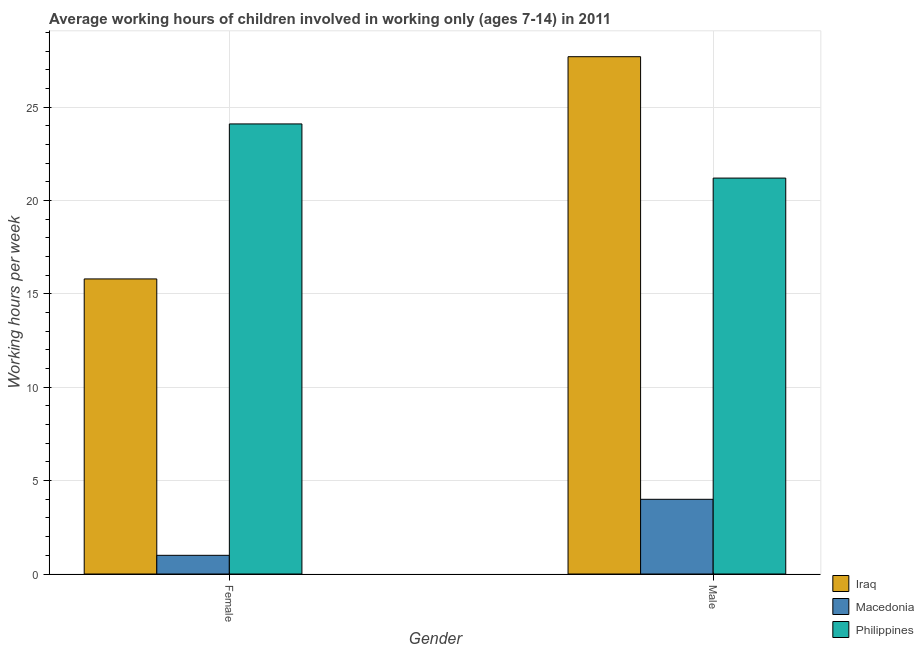Are the number of bars per tick equal to the number of legend labels?
Your answer should be very brief. Yes. How many bars are there on the 2nd tick from the left?
Provide a succinct answer. 3. How many bars are there on the 2nd tick from the right?
Provide a succinct answer. 3. What is the average working hour of female children in Philippines?
Your response must be concise. 24.1. Across all countries, what is the maximum average working hour of male children?
Ensure brevity in your answer.  27.7. In which country was the average working hour of female children minimum?
Provide a short and direct response. Macedonia. What is the total average working hour of female children in the graph?
Make the answer very short. 40.9. What is the difference between the average working hour of female children in Macedonia and that in Philippines?
Make the answer very short. -23.1. What is the difference between the average working hour of male children in Iraq and the average working hour of female children in Philippines?
Provide a short and direct response. 3.6. What is the average average working hour of male children per country?
Provide a succinct answer. 17.63. What is the difference between the average working hour of female children and average working hour of male children in Iraq?
Provide a short and direct response. -11.9. What is the ratio of the average working hour of male children in Iraq to that in Macedonia?
Ensure brevity in your answer.  6.92. In how many countries, is the average working hour of female children greater than the average average working hour of female children taken over all countries?
Give a very brief answer. 2. What does the 3rd bar from the right in Female represents?
Give a very brief answer. Iraq. Are all the bars in the graph horizontal?
Provide a short and direct response. No. How many countries are there in the graph?
Give a very brief answer. 3. Are the values on the major ticks of Y-axis written in scientific E-notation?
Make the answer very short. No. Does the graph contain any zero values?
Provide a succinct answer. No. Does the graph contain grids?
Offer a very short reply. Yes. How many legend labels are there?
Your answer should be very brief. 3. How are the legend labels stacked?
Provide a short and direct response. Vertical. What is the title of the graph?
Your answer should be compact. Average working hours of children involved in working only (ages 7-14) in 2011. Does "Gambia, The" appear as one of the legend labels in the graph?
Your answer should be very brief. No. What is the label or title of the Y-axis?
Ensure brevity in your answer.  Working hours per week. What is the Working hours per week in Iraq in Female?
Make the answer very short. 15.8. What is the Working hours per week of Macedonia in Female?
Offer a very short reply. 1. What is the Working hours per week of Philippines in Female?
Provide a succinct answer. 24.1. What is the Working hours per week of Iraq in Male?
Give a very brief answer. 27.7. What is the Working hours per week in Philippines in Male?
Provide a short and direct response. 21.2. Across all Gender, what is the maximum Working hours per week in Iraq?
Give a very brief answer. 27.7. Across all Gender, what is the maximum Working hours per week in Macedonia?
Offer a very short reply. 4. Across all Gender, what is the maximum Working hours per week in Philippines?
Ensure brevity in your answer.  24.1. Across all Gender, what is the minimum Working hours per week in Iraq?
Your answer should be very brief. 15.8. Across all Gender, what is the minimum Working hours per week in Philippines?
Offer a very short reply. 21.2. What is the total Working hours per week in Iraq in the graph?
Keep it short and to the point. 43.5. What is the total Working hours per week of Macedonia in the graph?
Keep it short and to the point. 5. What is the total Working hours per week of Philippines in the graph?
Provide a succinct answer. 45.3. What is the difference between the Working hours per week in Iraq in Female and that in Male?
Keep it short and to the point. -11.9. What is the difference between the Working hours per week of Macedonia in Female and that in Male?
Ensure brevity in your answer.  -3. What is the difference between the Working hours per week in Iraq in Female and the Working hours per week in Philippines in Male?
Provide a succinct answer. -5.4. What is the difference between the Working hours per week in Macedonia in Female and the Working hours per week in Philippines in Male?
Your answer should be very brief. -20.2. What is the average Working hours per week of Iraq per Gender?
Make the answer very short. 21.75. What is the average Working hours per week in Macedonia per Gender?
Ensure brevity in your answer.  2.5. What is the average Working hours per week in Philippines per Gender?
Your answer should be compact. 22.65. What is the difference between the Working hours per week of Macedonia and Working hours per week of Philippines in Female?
Provide a short and direct response. -23.1. What is the difference between the Working hours per week of Iraq and Working hours per week of Macedonia in Male?
Keep it short and to the point. 23.7. What is the difference between the Working hours per week of Macedonia and Working hours per week of Philippines in Male?
Your answer should be very brief. -17.2. What is the ratio of the Working hours per week in Iraq in Female to that in Male?
Your answer should be very brief. 0.57. What is the ratio of the Working hours per week in Macedonia in Female to that in Male?
Your answer should be very brief. 0.25. What is the ratio of the Working hours per week in Philippines in Female to that in Male?
Your response must be concise. 1.14. What is the difference between the highest and the second highest Working hours per week of Macedonia?
Provide a short and direct response. 3. What is the difference between the highest and the lowest Working hours per week in Iraq?
Your response must be concise. 11.9. 